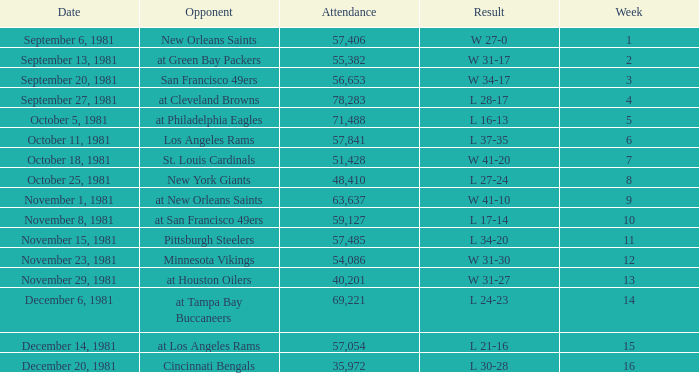On what date did the team play againt the New Orleans Saints? September 6, 1981. 